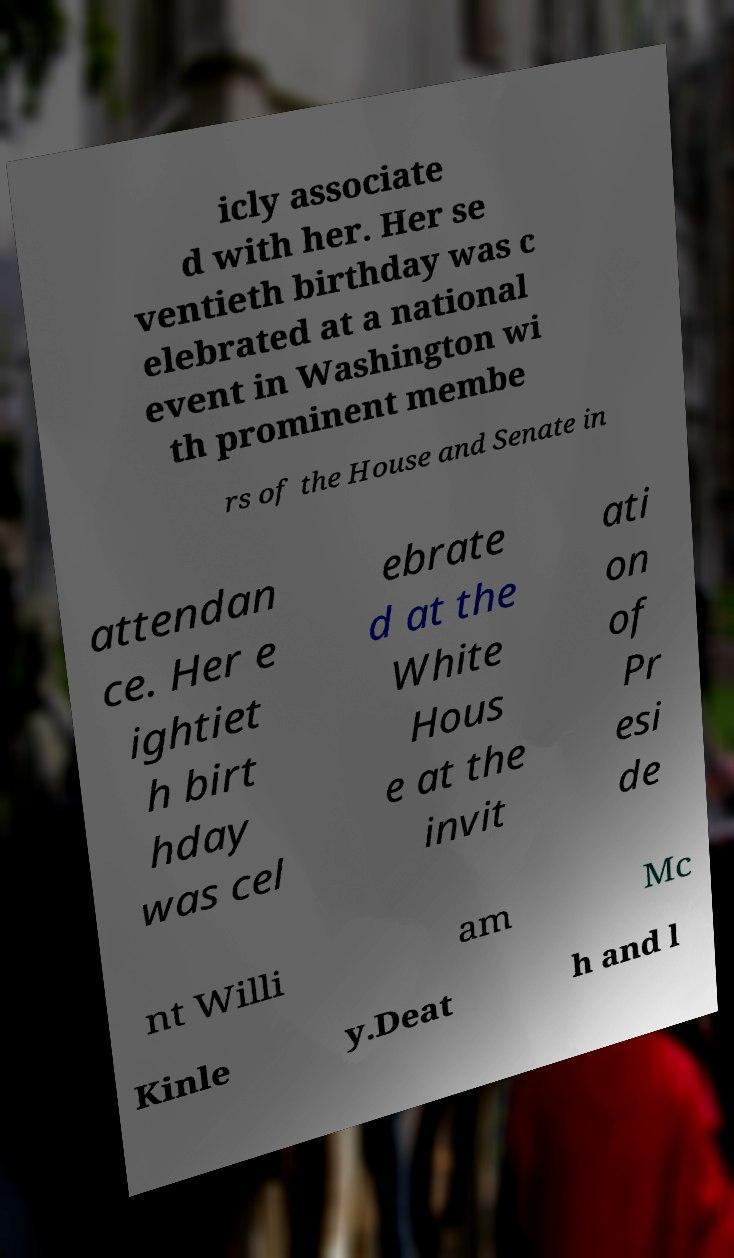Can you read and provide the text displayed in the image?This photo seems to have some interesting text. Can you extract and type it out for me? icly associate d with her. Her se ventieth birthday was c elebrated at a national event in Washington wi th prominent membe rs of the House and Senate in attendan ce. Her e ightiet h birt hday was cel ebrate d at the White Hous e at the invit ati on of Pr esi de nt Willi am Mc Kinle y.Deat h and l 